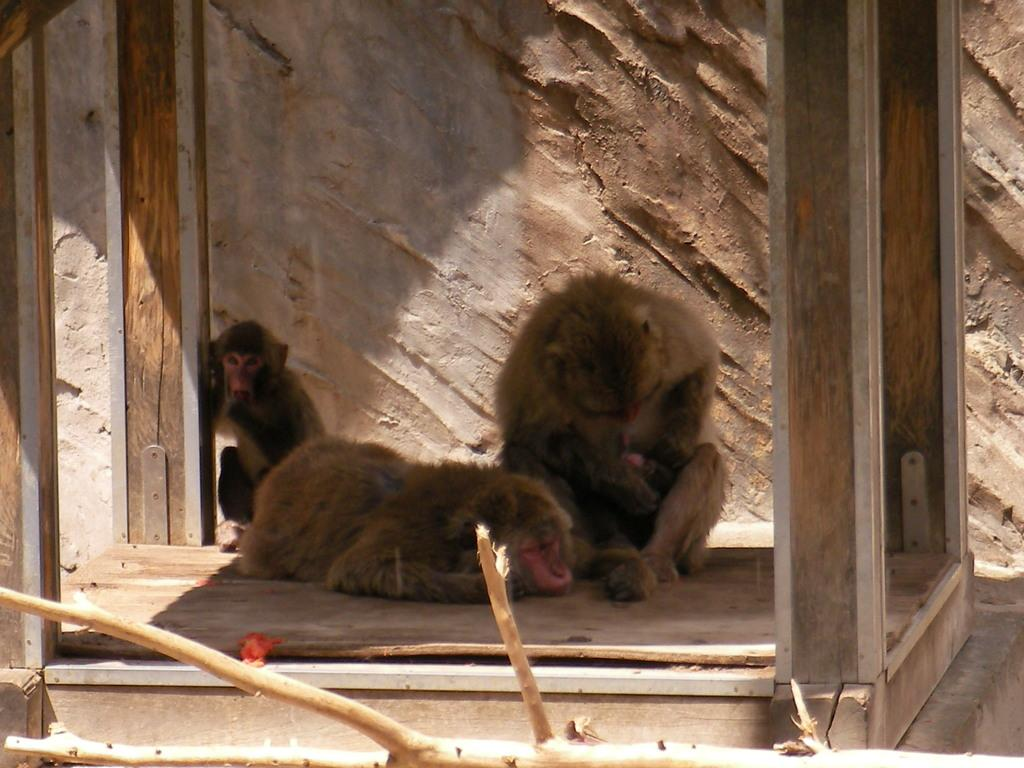What animals are present in the image? There are monkeys in the image. Where are the monkeys located? The monkeys are sitting in a cage. What type of breakfast is the monkey eating in the image? There is no breakfast present in the image; it only shows monkeys sitting in a cage. 